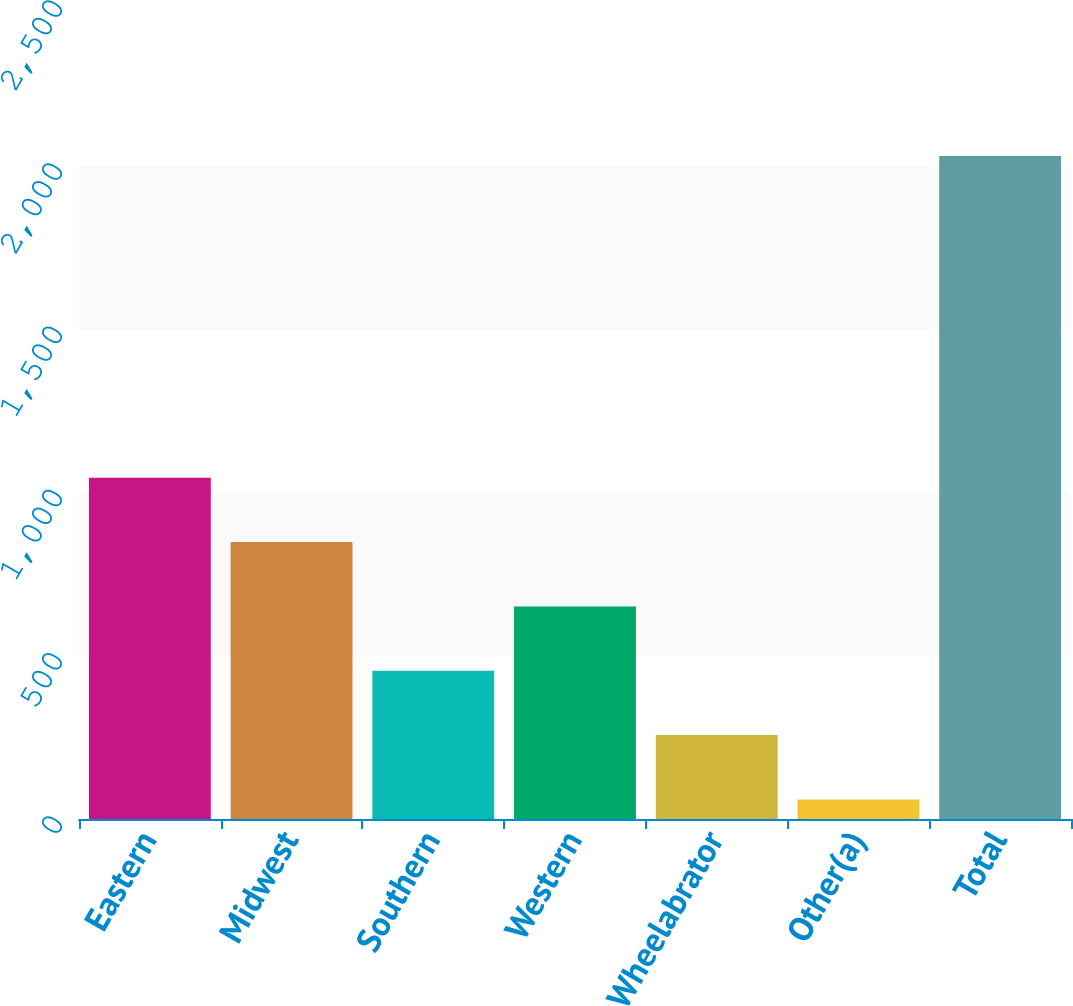<chart> <loc_0><loc_0><loc_500><loc_500><bar_chart><fcel>Eastern<fcel>Midwest<fcel>Southern<fcel>Western<fcel>Wheelabrator<fcel>Other(a)<fcel>Total<nl><fcel>1045.5<fcel>848.4<fcel>454.2<fcel>651.3<fcel>257.1<fcel>60<fcel>2031<nl></chart> 